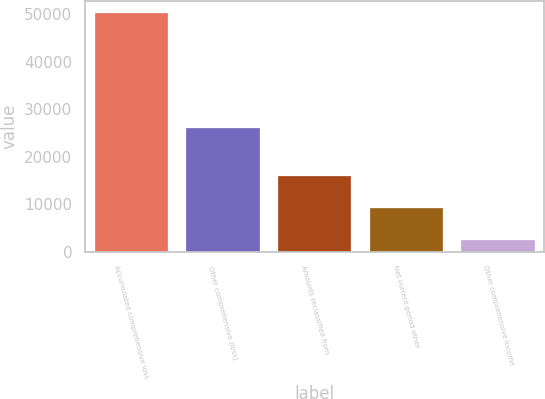<chart> <loc_0><loc_0><loc_500><loc_500><bar_chart><fcel>Accumulated comprehensive loss<fcel>Other comprehensive (loss)<fcel>Amounts reclassified from<fcel>Net current-period other<fcel>Other comprehensive income<nl><fcel>50244<fcel>25952<fcel>15872.2<fcel>9117.1<fcel>2362<nl></chart> 